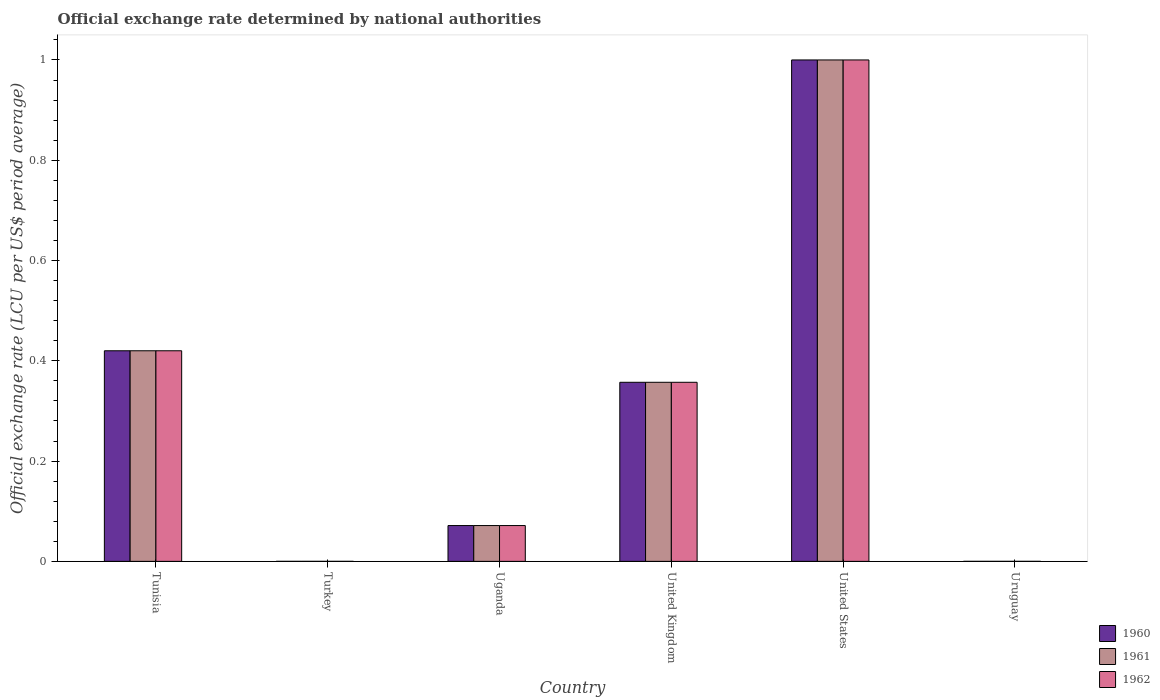How many different coloured bars are there?
Provide a short and direct response. 3. How many bars are there on the 6th tick from the left?
Ensure brevity in your answer.  3. How many bars are there on the 2nd tick from the right?
Your answer should be compact. 3. What is the official exchange rate in 1961 in Uruguay?
Offer a very short reply. 1.10091666666667e-5. Across all countries, what is the maximum official exchange rate in 1962?
Ensure brevity in your answer.  1. Across all countries, what is the minimum official exchange rate in 1960?
Keep it short and to the point. 9.01691666658333e-6. In which country was the official exchange rate in 1961 maximum?
Your response must be concise. United States. In which country was the official exchange rate in 1962 minimum?
Provide a short and direct response. Turkey. What is the total official exchange rate in 1961 in the graph?
Ensure brevity in your answer.  1.85. What is the difference between the official exchange rate in 1960 in Turkey and that in Uruguay?
Your answer should be compact. -2.2797500000833697e-6. What is the difference between the official exchange rate in 1962 in United Kingdom and the official exchange rate in 1961 in United States?
Provide a short and direct response. -0.64. What is the average official exchange rate in 1962 per country?
Provide a short and direct response. 0.31. In how many countries, is the official exchange rate in 1960 greater than 0.52 LCU?
Provide a succinct answer. 1. What is the ratio of the official exchange rate in 1961 in Uganda to that in United Kingdom?
Keep it short and to the point. 0.2. What is the difference between the highest and the second highest official exchange rate in 1962?
Ensure brevity in your answer.  -0.58. What is the difference between the highest and the lowest official exchange rate in 1962?
Your answer should be compact. 1. In how many countries, is the official exchange rate in 1961 greater than the average official exchange rate in 1961 taken over all countries?
Provide a succinct answer. 3. Is the sum of the official exchange rate in 1960 in Tunisia and United States greater than the maximum official exchange rate in 1962 across all countries?
Your response must be concise. Yes. What does the 3rd bar from the right in Uganda represents?
Offer a terse response. 1960. How many bars are there?
Offer a terse response. 18. What is the difference between two consecutive major ticks on the Y-axis?
Provide a succinct answer. 0.2. Are the values on the major ticks of Y-axis written in scientific E-notation?
Make the answer very short. No. Does the graph contain any zero values?
Make the answer very short. No. Does the graph contain grids?
Your answer should be very brief. No. How many legend labels are there?
Provide a succinct answer. 3. What is the title of the graph?
Your answer should be very brief. Official exchange rate determined by national authorities. What is the label or title of the Y-axis?
Keep it short and to the point. Official exchange rate (LCU per US$ period average). What is the Official exchange rate (LCU per US$ period average) of 1960 in Tunisia?
Your answer should be very brief. 0.42. What is the Official exchange rate (LCU per US$ period average) of 1961 in Tunisia?
Your answer should be compact. 0.42. What is the Official exchange rate (LCU per US$ period average) in 1962 in Tunisia?
Offer a very short reply. 0.42. What is the Official exchange rate (LCU per US$ period average) in 1960 in Turkey?
Provide a succinct answer. 9.01691666658333e-6. What is the Official exchange rate (LCU per US$ period average) of 1961 in Turkey?
Your answer should be very brief. 9.02e-6. What is the Official exchange rate (LCU per US$ period average) of 1962 in Turkey?
Provide a short and direct response. 9.02e-6. What is the Official exchange rate (LCU per US$ period average) in 1960 in Uganda?
Your answer should be very brief. 0.07. What is the Official exchange rate (LCU per US$ period average) in 1961 in Uganda?
Offer a very short reply. 0.07. What is the Official exchange rate (LCU per US$ period average) in 1962 in Uganda?
Provide a succinct answer. 0.07. What is the Official exchange rate (LCU per US$ period average) of 1960 in United Kingdom?
Offer a very short reply. 0.36. What is the Official exchange rate (LCU per US$ period average) of 1961 in United Kingdom?
Make the answer very short. 0.36. What is the Official exchange rate (LCU per US$ period average) in 1962 in United Kingdom?
Give a very brief answer. 0.36. What is the Official exchange rate (LCU per US$ period average) of 1961 in United States?
Your answer should be very brief. 1. What is the Official exchange rate (LCU per US$ period average) in 1962 in United States?
Keep it short and to the point. 1. What is the Official exchange rate (LCU per US$ period average) of 1960 in Uruguay?
Your answer should be compact. 1.12966666666667e-5. What is the Official exchange rate (LCU per US$ period average) of 1961 in Uruguay?
Give a very brief answer. 1.10091666666667e-5. What is the Official exchange rate (LCU per US$ period average) in 1962 in Uruguay?
Offer a terse response. 1.098e-5. Across all countries, what is the minimum Official exchange rate (LCU per US$ period average) in 1960?
Keep it short and to the point. 9.01691666658333e-6. Across all countries, what is the minimum Official exchange rate (LCU per US$ period average) of 1961?
Make the answer very short. 9.02e-6. Across all countries, what is the minimum Official exchange rate (LCU per US$ period average) of 1962?
Keep it short and to the point. 9.02e-6. What is the total Official exchange rate (LCU per US$ period average) of 1960 in the graph?
Your response must be concise. 1.85. What is the total Official exchange rate (LCU per US$ period average) of 1961 in the graph?
Keep it short and to the point. 1.85. What is the total Official exchange rate (LCU per US$ period average) in 1962 in the graph?
Your response must be concise. 1.85. What is the difference between the Official exchange rate (LCU per US$ period average) in 1960 in Tunisia and that in Turkey?
Ensure brevity in your answer.  0.42. What is the difference between the Official exchange rate (LCU per US$ period average) of 1961 in Tunisia and that in Turkey?
Keep it short and to the point. 0.42. What is the difference between the Official exchange rate (LCU per US$ period average) in 1962 in Tunisia and that in Turkey?
Provide a succinct answer. 0.42. What is the difference between the Official exchange rate (LCU per US$ period average) in 1960 in Tunisia and that in Uganda?
Offer a terse response. 0.35. What is the difference between the Official exchange rate (LCU per US$ period average) of 1961 in Tunisia and that in Uganda?
Your answer should be very brief. 0.35. What is the difference between the Official exchange rate (LCU per US$ period average) in 1962 in Tunisia and that in Uganda?
Provide a succinct answer. 0.35. What is the difference between the Official exchange rate (LCU per US$ period average) in 1960 in Tunisia and that in United Kingdom?
Offer a very short reply. 0.06. What is the difference between the Official exchange rate (LCU per US$ period average) in 1961 in Tunisia and that in United Kingdom?
Offer a very short reply. 0.06. What is the difference between the Official exchange rate (LCU per US$ period average) in 1962 in Tunisia and that in United Kingdom?
Keep it short and to the point. 0.06. What is the difference between the Official exchange rate (LCU per US$ period average) in 1960 in Tunisia and that in United States?
Provide a succinct answer. -0.58. What is the difference between the Official exchange rate (LCU per US$ period average) in 1961 in Tunisia and that in United States?
Give a very brief answer. -0.58. What is the difference between the Official exchange rate (LCU per US$ period average) in 1962 in Tunisia and that in United States?
Your answer should be compact. -0.58. What is the difference between the Official exchange rate (LCU per US$ period average) in 1960 in Tunisia and that in Uruguay?
Ensure brevity in your answer.  0.42. What is the difference between the Official exchange rate (LCU per US$ period average) of 1961 in Tunisia and that in Uruguay?
Your answer should be very brief. 0.42. What is the difference between the Official exchange rate (LCU per US$ period average) in 1962 in Tunisia and that in Uruguay?
Your answer should be very brief. 0.42. What is the difference between the Official exchange rate (LCU per US$ period average) of 1960 in Turkey and that in Uganda?
Your answer should be very brief. -0.07. What is the difference between the Official exchange rate (LCU per US$ period average) in 1961 in Turkey and that in Uganda?
Keep it short and to the point. -0.07. What is the difference between the Official exchange rate (LCU per US$ period average) in 1962 in Turkey and that in Uganda?
Your response must be concise. -0.07. What is the difference between the Official exchange rate (LCU per US$ period average) in 1960 in Turkey and that in United Kingdom?
Keep it short and to the point. -0.36. What is the difference between the Official exchange rate (LCU per US$ period average) of 1961 in Turkey and that in United Kingdom?
Ensure brevity in your answer.  -0.36. What is the difference between the Official exchange rate (LCU per US$ period average) in 1962 in Turkey and that in United Kingdom?
Your response must be concise. -0.36. What is the difference between the Official exchange rate (LCU per US$ period average) of 1960 in Turkey and that in United States?
Give a very brief answer. -1. What is the difference between the Official exchange rate (LCU per US$ period average) of 1961 in Turkey and that in United States?
Your answer should be compact. -1. What is the difference between the Official exchange rate (LCU per US$ period average) in 1960 in Uganda and that in United Kingdom?
Provide a succinct answer. -0.29. What is the difference between the Official exchange rate (LCU per US$ period average) in 1961 in Uganda and that in United Kingdom?
Offer a very short reply. -0.29. What is the difference between the Official exchange rate (LCU per US$ period average) in 1962 in Uganda and that in United Kingdom?
Keep it short and to the point. -0.29. What is the difference between the Official exchange rate (LCU per US$ period average) of 1960 in Uganda and that in United States?
Your response must be concise. -0.93. What is the difference between the Official exchange rate (LCU per US$ period average) in 1961 in Uganda and that in United States?
Offer a terse response. -0.93. What is the difference between the Official exchange rate (LCU per US$ period average) in 1962 in Uganda and that in United States?
Provide a short and direct response. -0.93. What is the difference between the Official exchange rate (LCU per US$ period average) in 1960 in Uganda and that in Uruguay?
Your answer should be compact. 0.07. What is the difference between the Official exchange rate (LCU per US$ period average) of 1961 in Uganda and that in Uruguay?
Keep it short and to the point. 0.07. What is the difference between the Official exchange rate (LCU per US$ period average) in 1962 in Uganda and that in Uruguay?
Offer a terse response. 0.07. What is the difference between the Official exchange rate (LCU per US$ period average) in 1960 in United Kingdom and that in United States?
Keep it short and to the point. -0.64. What is the difference between the Official exchange rate (LCU per US$ period average) in 1961 in United Kingdom and that in United States?
Your answer should be very brief. -0.64. What is the difference between the Official exchange rate (LCU per US$ period average) in 1962 in United Kingdom and that in United States?
Your answer should be compact. -0.64. What is the difference between the Official exchange rate (LCU per US$ period average) of 1960 in United Kingdom and that in Uruguay?
Offer a terse response. 0.36. What is the difference between the Official exchange rate (LCU per US$ period average) in 1961 in United Kingdom and that in Uruguay?
Provide a succinct answer. 0.36. What is the difference between the Official exchange rate (LCU per US$ period average) in 1962 in United Kingdom and that in Uruguay?
Provide a short and direct response. 0.36. What is the difference between the Official exchange rate (LCU per US$ period average) in 1960 in United States and that in Uruguay?
Provide a short and direct response. 1. What is the difference between the Official exchange rate (LCU per US$ period average) in 1961 in United States and that in Uruguay?
Provide a short and direct response. 1. What is the difference between the Official exchange rate (LCU per US$ period average) of 1962 in United States and that in Uruguay?
Keep it short and to the point. 1. What is the difference between the Official exchange rate (LCU per US$ period average) in 1960 in Tunisia and the Official exchange rate (LCU per US$ period average) in 1961 in Turkey?
Your response must be concise. 0.42. What is the difference between the Official exchange rate (LCU per US$ period average) in 1960 in Tunisia and the Official exchange rate (LCU per US$ period average) in 1962 in Turkey?
Provide a short and direct response. 0.42. What is the difference between the Official exchange rate (LCU per US$ period average) in 1961 in Tunisia and the Official exchange rate (LCU per US$ period average) in 1962 in Turkey?
Ensure brevity in your answer.  0.42. What is the difference between the Official exchange rate (LCU per US$ period average) in 1960 in Tunisia and the Official exchange rate (LCU per US$ period average) in 1961 in Uganda?
Give a very brief answer. 0.35. What is the difference between the Official exchange rate (LCU per US$ period average) of 1960 in Tunisia and the Official exchange rate (LCU per US$ period average) of 1962 in Uganda?
Your answer should be compact. 0.35. What is the difference between the Official exchange rate (LCU per US$ period average) in 1961 in Tunisia and the Official exchange rate (LCU per US$ period average) in 1962 in Uganda?
Provide a short and direct response. 0.35. What is the difference between the Official exchange rate (LCU per US$ period average) in 1960 in Tunisia and the Official exchange rate (LCU per US$ period average) in 1961 in United Kingdom?
Keep it short and to the point. 0.06. What is the difference between the Official exchange rate (LCU per US$ period average) in 1960 in Tunisia and the Official exchange rate (LCU per US$ period average) in 1962 in United Kingdom?
Ensure brevity in your answer.  0.06. What is the difference between the Official exchange rate (LCU per US$ period average) in 1961 in Tunisia and the Official exchange rate (LCU per US$ period average) in 1962 in United Kingdom?
Provide a succinct answer. 0.06. What is the difference between the Official exchange rate (LCU per US$ period average) in 1960 in Tunisia and the Official exchange rate (LCU per US$ period average) in 1961 in United States?
Ensure brevity in your answer.  -0.58. What is the difference between the Official exchange rate (LCU per US$ period average) of 1960 in Tunisia and the Official exchange rate (LCU per US$ period average) of 1962 in United States?
Give a very brief answer. -0.58. What is the difference between the Official exchange rate (LCU per US$ period average) of 1961 in Tunisia and the Official exchange rate (LCU per US$ period average) of 1962 in United States?
Offer a very short reply. -0.58. What is the difference between the Official exchange rate (LCU per US$ period average) in 1960 in Tunisia and the Official exchange rate (LCU per US$ period average) in 1961 in Uruguay?
Give a very brief answer. 0.42. What is the difference between the Official exchange rate (LCU per US$ period average) of 1960 in Tunisia and the Official exchange rate (LCU per US$ period average) of 1962 in Uruguay?
Ensure brevity in your answer.  0.42. What is the difference between the Official exchange rate (LCU per US$ period average) in 1961 in Tunisia and the Official exchange rate (LCU per US$ period average) in 1962 in Uruguay?
Offer a very short reply. 0.42. What is the difference between the Official exchange rate (LCU per US$ period average) in 1960 in Turkey and the Official exchange rate (LCU per US$ period average) in 1961 in Uganda?
Your answer should be compact. -0.07. What is the difference between the Official exchange rate (LCU per US$ period average) in 1960 in Turkey and the Official exchange rate (LCU per US$ period average) in 1962 in Uganda?
Provide a short and direct response. -0.07. What is the difference between the Official exchange rate (LCU per US$ period average) in 1961 in Turkey and the Official exchange rate (LCU per US$ period average) in 1962 in Uganda?
Offer a terse response. -0.07. What is the difference between the Official exchange rate (LCU per US$ period average) in 1960 in Turkey and the Official exchange rate (LCU per US$ period average) in 1961 in United Kingdom?
Keep it short and to the point. -0.36. What is the difference between the Official exchange rate (LCU per US$ period average) in 1960 in Turkey and the Official exchange rate (LCU per US$ period average) in 1962 in United Kingdom?
Your response must be concise. -0.36. What is the difference between the Official exchange rate (LCU per US$ period average) of 1961 in Turkey and the Official exchange rate (LCU per US$ period average) of 1962 in United Kingdom?
Keep it short and to the point. -0.36. What is the difference between the Official exchange rate (LCU per US$ period average) of 1960 in Turkey and the Official exchange rate (LCU per US$ period average) of 1961 in United States?
Ensure brevity in your answer.  -1. What is the difference between the Official exchange rate (LCU per US$ period average) of 1961 in Turkey and the Official exchange rate (LCU per US$ period average) of 1962 in Uruguay?
Your answer should be compact. -0. What is the difference between the Official exchange rate (LCU per US$ period average) in 1960 in Uganda and the Official exchange rate (LCU per US$ period average) in 1961 in United Kingdom?
Provide a short and direct response. -0.29. What is the difference between the Official exchange rate (LCU per US$ period average) of 1960 in Uganda and the Official exchange rate (LCU per US$ period average) of 1962 in United Kingdom?
Provide a succinct answer. -0.29. What is the difference between the Official exchange rate (LCU per US$ period average) of 1961 in Uganda and the Official exchange rate (LCU per US$ period average) of 1962 in United Kingdom?
Your answer should be compact. -0.29. What is the difference between the Official exchange rate (LCU per US$ period average) in 1960 in Uganda and the Official exchange rate (LCU per US$ period average) in 1961 in United States?
Offer a very short reply. -0.93. What is the difference between the Official exchange rate (LCU per US$ period average) in 1960 in Uganda and the Official exchange rate (LCU per US$ period average) in 1962 in United States?
Offer a terse response. -0.93. What is the difference between the Official exchange rate (LCU per US$ period average) in 1961 in Uganda and the Official exchange rate (LCU per US$ period average) in 1962 in United States?
Ensure brevity in your answer.  -0.93. What is the difference between the Official exchange rate (LCU per US$ period average) in 1960 in Uganda and the Official exchange rate (LCU per US$ period average) in 1961 in Uruguay?
Your answer should be compact. 0.07. What is the difference between the Official exchange rate (LCU per US$ period average) of 1960 in Uganda and the Official exchange rate (LCU per US$ period average) of 1962 in Uruguay?
Keep it short and to the point. 0.07. What is the difference between the Official exchange rate (LCU per US$ period average) in 1961 in Uganda and the Official exchange rate (LCU per US$ period average) in 1962 in Uruguay?
Your answer should be compact. 0.07. What is the difference between the Official exchange rate (LCU per US$ period average) of 1960 in United Kingdom and the Official exchange rate (LCU per US$ period average) of 1961 in United States?
Provide a succinct answer. -0.64. What is the difference between the Official exchange rate (LCU per US$ period average) of 1960 in United Kingdom and the Official exchange rate (LCU per US$ period average) of 1962 in United States?
Give a very brief answer. -0.64. What is the difference between the Official exchange rate (LCU per US$ period average) of 1961 in United Kingdom and the Official exchange rate (LCU per US$ period average) of 1962 in United States?
Give a very brief answer. -0.64. What is the difference between the Official exchange rate (LCU per US$ period average) in 1960 in United Kingdom and the Official exchange rate (LCU per US$ period average) in 1961 in Uruguay?
Provide a short and direct response. 0.36. What is the difference between the Official exchange rate (LCU per US$ period average) in 1960 in United Kingdom and the Official exchange rate (LCU per US$ period average) in 1962 in Uruguay?
Your answer should be compact. 0.36. What is the difference between the Official exchange rate (LCU per US$ period average) of 1961 in United Kingdom and the Official exchange rate (LCU per US$ period average) of 1962 in Uruguay?
Give a very brief answer. 0.36. What is the difference between the Official exchange rate (LCU per US$ period average) of 1960 in United States and the Official exchange rate (LCU per US$ period average) of 1962 in Uruguay?
Provide a succinct answer. 1. What is the average Official exchange rate (LCU per US$ period average) in 1960 per country?
Your response must be concise. 0.31. What is the average Official exchange rate (LCU per US$ period average) of 1961 per country?
Your answer should be compact. 0.31. What is the average Official exchange rate (LCU per US$ period average) in 1962 per country?
Make the answer very short. 0.31. What is the difference between the Official exchange rate (LCU per US$ period average) of 1960 and Official exchange rate (LCU per US$ period average) of 1961 in Tunisia?
Your answer should be compact. 0. What is the difference between the Official exchange rate (LCU per US$ period average) in 1960 and Official exchange rate (LCU per US$ period average) in 1961 in Turkey?
Your answer should be very brief. -0. What is the difference between the Official exchange rate (LCU per US$ period average) of 1960 and Official exchange rate (LCU per US$ period average) of 1962 in Turkey?
Provide a short and direct response. -0. What is the difference between the Official exchange rate (LCU per US$ period average) of 1960 and Official exchange rate (LCU per US$ period average) of 1962 in Uganda?
Your response must be concise. 0. What is the difference between the Official exchange rate (LCU per US$ period average) in 1960 and Official exchange rate (LCU per US$ period average) in 1962 in United Kingdom?
Ensure brevity in your answer.  0. What is the difference between the Official exchange rate (LCU per US$ period average) of 1960 and Official exchange rate (LCU per US$ period average) of 1961 in United States?
Provide a succinct answer. 0. What is the difference between the Official exchange rate (LCU per US$ period average) of 1960 and Official exchange rate (LCU per US$ period average) of 1962 in United States?
Give a very brief answer. 0. What is the ratio of the Official exchange rate (LCU per US$ period average) in 1960 in Tunisia to that in Turkey?
Provide a short and direct response. 4.66e+04. What is the ratio of the Official exchange rate (LCU per US$ period average) in 1961 in Tunisia to that in Turkey?
Provide a succinct answer. 4.66e+04. What is the ratio of the Official exchange rate (LCU per US$ period average) of 1962 in Tunisia to that in Turkey?
Offer a very short reply. 4.66e+04. What is the ratio of the Official exchange rate (LCU per US$ period average) in 1960 in Tunisia to that in Uganda?
Provide a short and direct response. 5.88. What is the ratio of the Official exchange rate (LCU per US$ period average) in 1961 in Tunisia to that in Uganda?
Make the answer very short. 5.88. What is the ratio of the Official exchange rate (LCU per US$ period average) of 1962 in Tunisia to that in Uganda?
Your answer should be very brief. 5.88. What is the ratio of the Official exchange rate (LCU per US$ period average) of 1960 in Tunisia to that in United Kingdom?
Your answer should be very brief. 1.18. What is the ratio of the Official exchange rate (LCU per US$ period average) in 1961 in Tunisia to that in United Kingdom?
Keep it short and to the point. 1.18. What is the ratio of the Official exchange rate (LCU per US$ period average) of 1962 in Tunisia to that in United Kingdom?
Your answer should be very brief. 1.18. What is the ratio of the Official exchange rate (LCU per US$ period average) of 1960 in Tunisia to that in United States?
Offer a terse response. 0.42. What is the ratio of the Official exchange rate (LCU per US$ period average) in 1961 in Tunisia to that in United States?
Keep it short and to the point. 0.42. What is the ratio of the Official exchange rate (LCU per US$ period average) of 1962 in Tunisia to that in United States?
Ensure brevity in your answer.  0.42. What is the ratio of the Official exchange rate (LCU per US$ period average) of 1960 in Tunisia to that in Uruguay?
Make the answer very short. 3.72e+04. What is the ratio of the Official exchange rate (LCU per US$ period average) of 1961 in Tunisia to that in Uruguay?
Ensure brevity in your answer.  3.82e+04. What is the ratio of the Official exchange rate (LCU per US$ period average) in 1962 in Tunisia to that in Uruguay?
Your answer should be very brief. 3.83e+04. What is the ratio of the Official exchange rate (LCU per US$ period average) in 1960 in Turkey to that in Uganda?
Make the answer very short. 0. What is the ratio of the Official exchange rate (LCU per US$ period average) of 1960 in Turkey to that in United Kingdom?
Your answer should be compact. 0. What is the ratio of the Official exchange rate (LCU per US$ period average) in 1960 in Turkey to that in United States?
Offer a very short reply. 0. What is the ratio of the Official exchange rate (LCU per US$ period average) in 1962 in Turkey to that in United States?
Your response must be concise. 0. What is the ratio of the Official exchange rate (LCU per US$ period average) in 1960 in Turkey to that in Uruguay?
Offer a terse response. 0.8. What is the ratio of the Official exchange rate (LCU per US$ period average) in 1961 in Turkey to that in Uruguay?
Your answer should be very brief. 0.82. What is the ratio of the Official exchange rate (LCU per US$ period average) of 1962 in Turkey to that in Uruguay?
Provide a short and direct response. 0.82. What is the ratio of the Official exchange rate (LCU per US$ period average) in 1960 in Uganda to that in United Kingdom?
Keep it short and to the point. 0.2. What is the ratio of the Official exchange rate (LCU per US$ period average) in 1960 in Uganda to that in United States?
Give a very brief answer. 0.07. What is the ratio of the Official exchange rate (LCU per US$ period average) of 1961 in Uganda to that in United States?
Offer a very short reply. 0.07. What is the ratio of the Official exchange rate (LCU per US$ period average) of 1962 in Uganda to that in United States?
Provide a short and direct response. 0.07. What is the ratio of the Official exchange rate (LCU per US$ period average) in 1960 in Uganda to that in Uruguay?
Offer a terse response. 6323.1. What is the ratio of the Official exchange rate (LCU per US$ period average) of 1961 in Uganda to that in Uruguay?
Ensure brevity in your answer.  6488.23. What is the ratio of the Official exchange rate (LCU per US$ period average) of 1962 in Uganda to that in Uruguay?
Your response must be concise. 6505.46. What is the ratio of the Official exchange rate (LCU per US$ period average) in 1960 in United Kingdom to that in United States?
Make the answer very short. 0.36. What is the ratio of the Official exchange rate (LCU per US$ period average) in 1961 in United Kingdom to that in United States?
Your answer should be very brief. 0.36. What is the ratio of the Official exchange rate (LCU per US$ period average) of 1962 in United Kingdom to that in United States?
Your answer should be very brief. 0.36. What is the ratio of the Official exchange rate (LCU per US$ period average) in 1960 in United Kingdom to that in Uruguay?
Provide a short and direct response. 3.16e+04. What is the ratio of the Official exchange rate (LCU per US$ period average) of 1961 in United Kingdom to that in Uruguay?
Offer a very short reply. 3.24e+04. What is the ratio of the Official exchange rate (LCU per US$ period average) in 1962 in United Kingdom to that in Uruguay?
Offer a terse response. 3.25e+04. What is the ratio of the Official exchange rate (LCU per US$ period average) of 1960 in United States to that in Uruguay?
Your response must be concise. 8.85e+04. What is the ratio of the Official exchange rate (LCU per US$ period average) in 1961 in United States to that in Uruguay?
Offer a very short reply. 9.08e+04. What is the ratio of the Official exchange rate (LCU per US$ period average) of 1962 in United States to that in Uruguay?
Give a very brief answer. 9.11e+04. What is the difference between the highest and the second highest Official exchange rate (LCU per US$ period average) in 1960?
Offer a terse response. 0.58. What is the difference between the highest and the second highest Official exchange rate (LCU per US$ period average) in 1961?
Give a very brief answer. 0.58. What is the difference between the highest and the second highest Official exchange rate (LCU per US$ period average) of 1962?
Your answer should be very brief. 0.58. What is the difference between the highest and the lowest Official exchange rate (LCU per US$ period average) in 1960?
Keep it short and to the point. 1. What is the difference between the highest and the lowest Official exchange rate (LCU per US$ period average) in 1962?
Give a very brief answer. 1. 